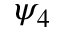Convert formula to latex. <formula><loc_0><loc_0><loc_500><loc_500>\psi _ { 4 }</formula> 